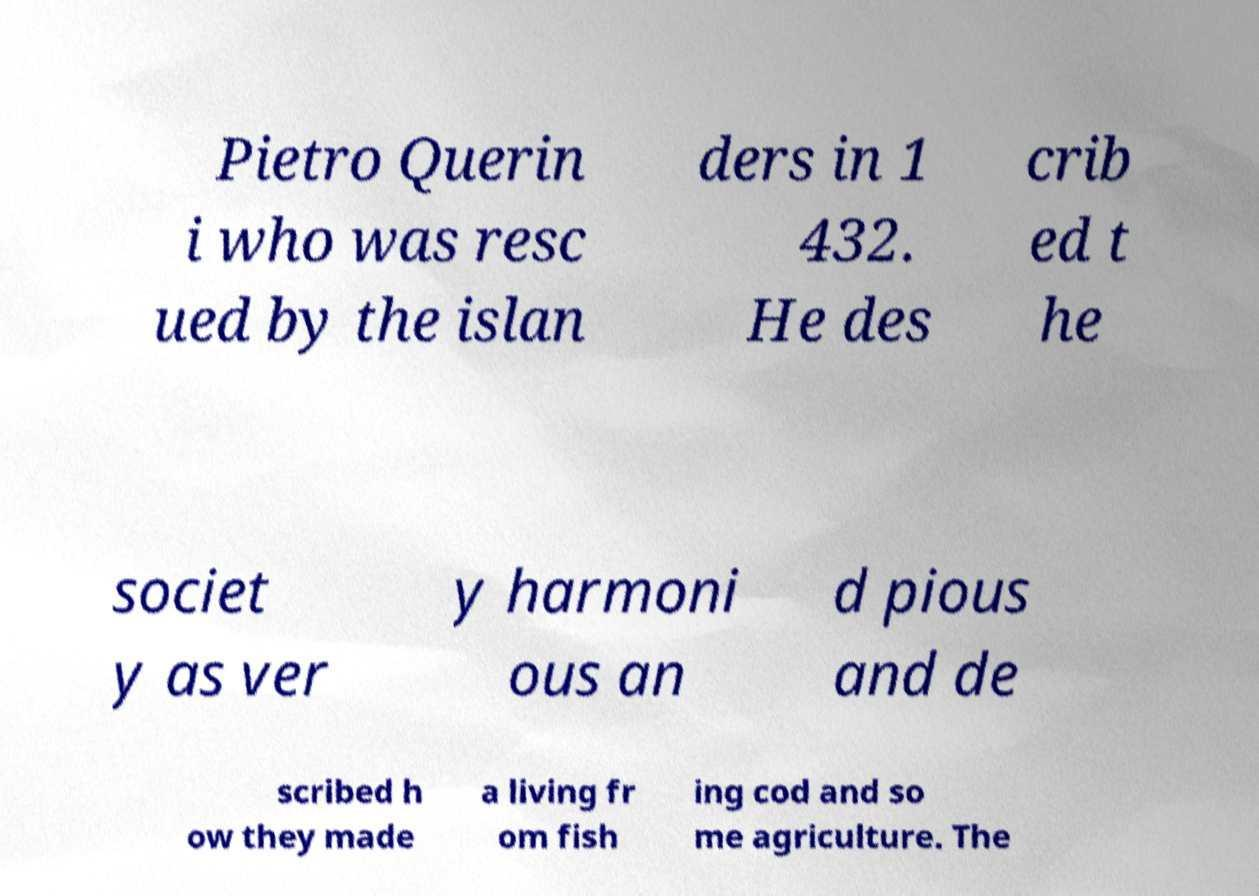Can you read and provide the text displayed in the image?This photo seems to have some interesting text. Can you extract and type it out for me? Pietro Querin i who was resc ued by the islan ders in 1 432. He des crib ed t he societ y as ver y harmoni ous an d pious and de scribed h ow they made a living fr om fish ing cod and so me agriculture. The 